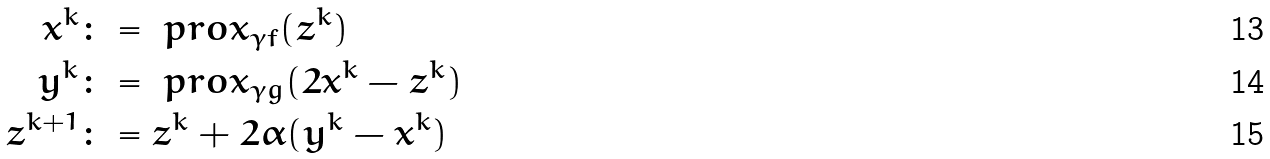<formula> <loc_0><loc_0><loc_500><loc_500>x ^ { k } & \colon = \ p r o x _ { \gamma f } ( z ^ { k } ) \\ y ^ { k } & \colon = \ p r o x _ { \gamma g } ( 2 x ^ { k } - z ^ { k } ) \\ z ^ { k + 1 } & \colon = z ^ { k } + 2 \alpha ( y ^ { k } - x ^ { k } )</formula> 